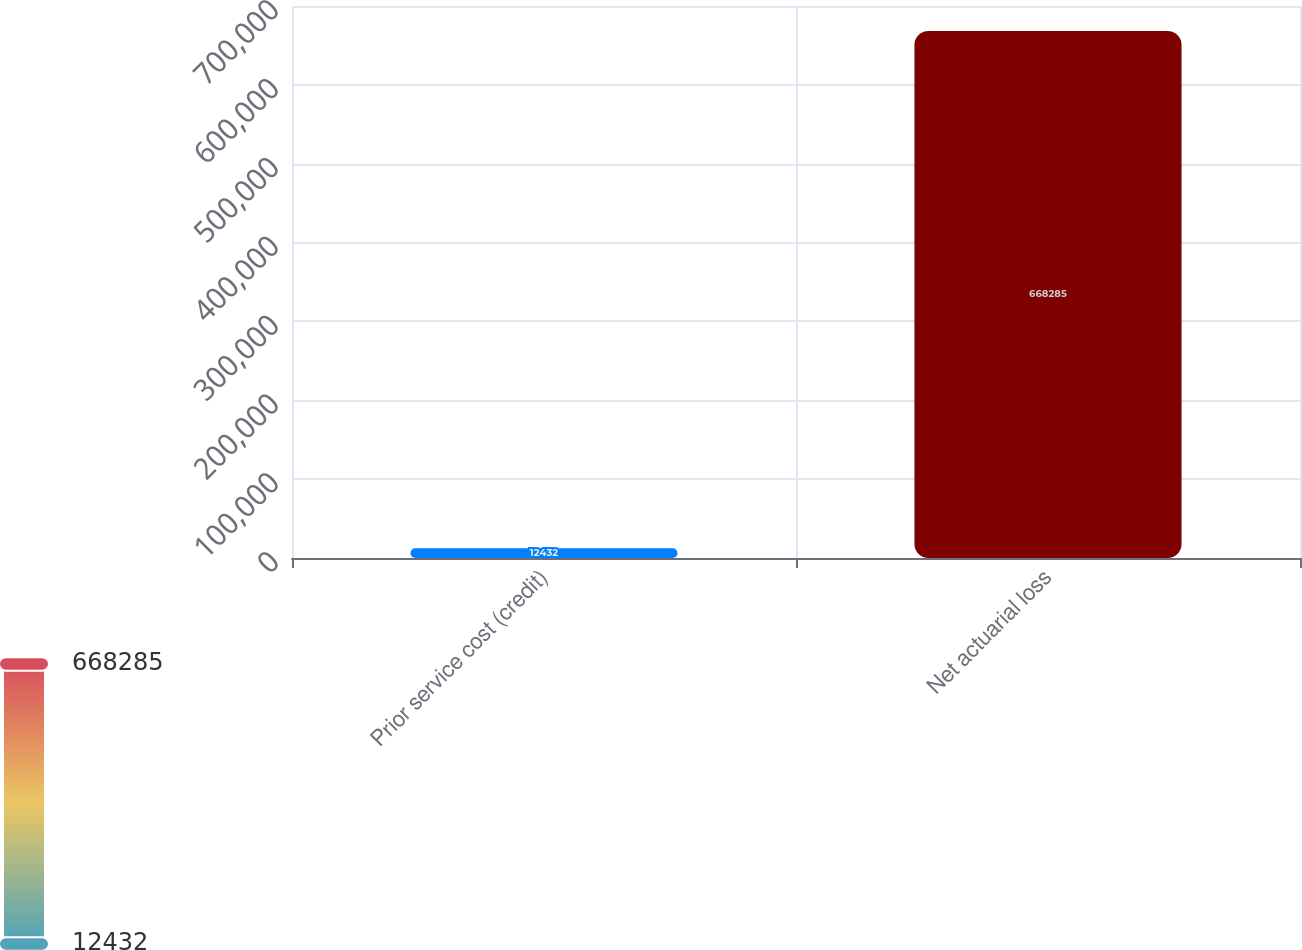Convert chart to OTSL. <chart><loc_0><loc_0><loc_500><loc_500><bar_chart><fcel>Prior service cost (credit)<fcel>Net actuarial loss<nl><fcel>12432<fcel>668285<nl></chart> 